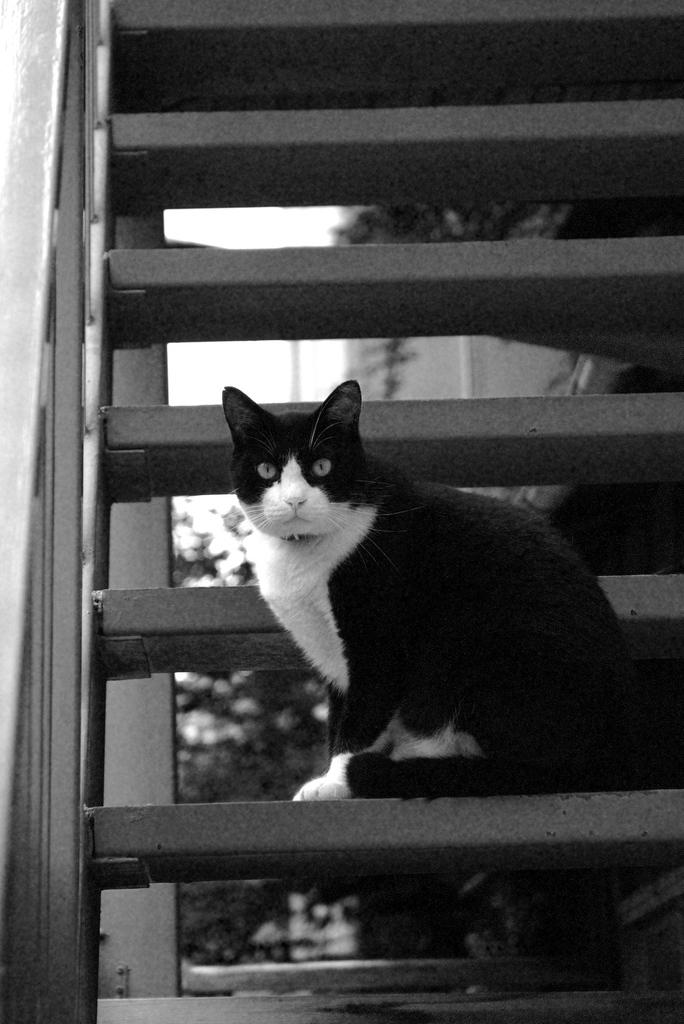What is the color scheme of the image? The image is black and white. What animal can be seen in the image? There is a cat in the image. Where is the cat located in the image? The cat is on a staircase. What can be seen in the background of the image? There are plants visible in the background of the image. What theory is the cat trying to prove in the image? There is no indication in the image that the cat is trying to prove a theory. 